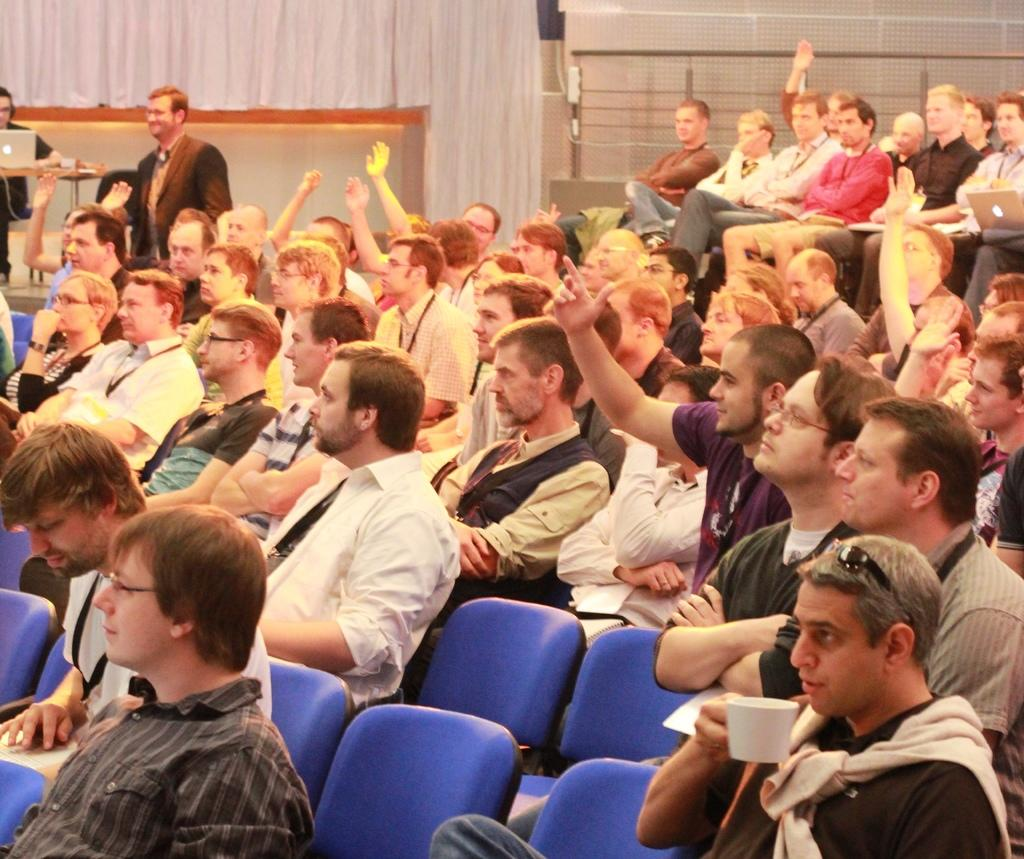What are the people in the image doing? The people in the image are sitting in the middle of the image. What are the people sitting on? The people are sitting on chairs. What can be seen on the left side of the image? There is a laptop on a table on the left side of the image. Who is standing beside the laptop? A man is standing beside the laptop. How many toes can be seen on the expert's foot in the image? There is no expert or foot visible in the image. What type of transportation are the passengers using in the image? There is no transportation or passengers present in the image. 